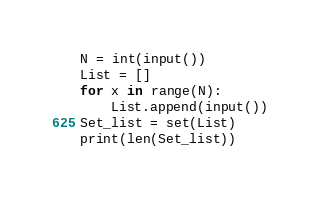<code> <loc_0><loc_0><loc_500><loc_500><_Python_>N = int(input())
List = []
for x in range(N):
    List.append(input())
Set_list = set(List)
print(len(Set_list))</code> 